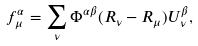<formula> <loc_0><loc_0><loc_500><loc_500>f _ { \mu } ^ { \alpha } = \sum _ { \nu } \Phi ^ { \alpha \beta } ( { R } _ { \nu } - { R } _ { \mu } ) U _ { \nu } ^ { \beta } ,</formula> 